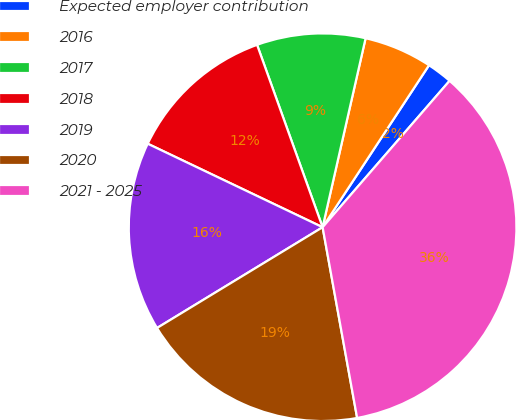<chart> <loc_0><loc_0><loc_500><loc_500><pie_chart><fcel>Expected employer contribution<fcel>2016<fcel>2017<fcel>2018<fcel>2019<fcel>2020<fcel>2021 - 2025<nl><fcel>2.12%<fcel>5.69%<fcel>9.05%<fcel>12.42%<fcel>15.79%<fcel>19.15%<fcel>35.78%<nl></chart> 